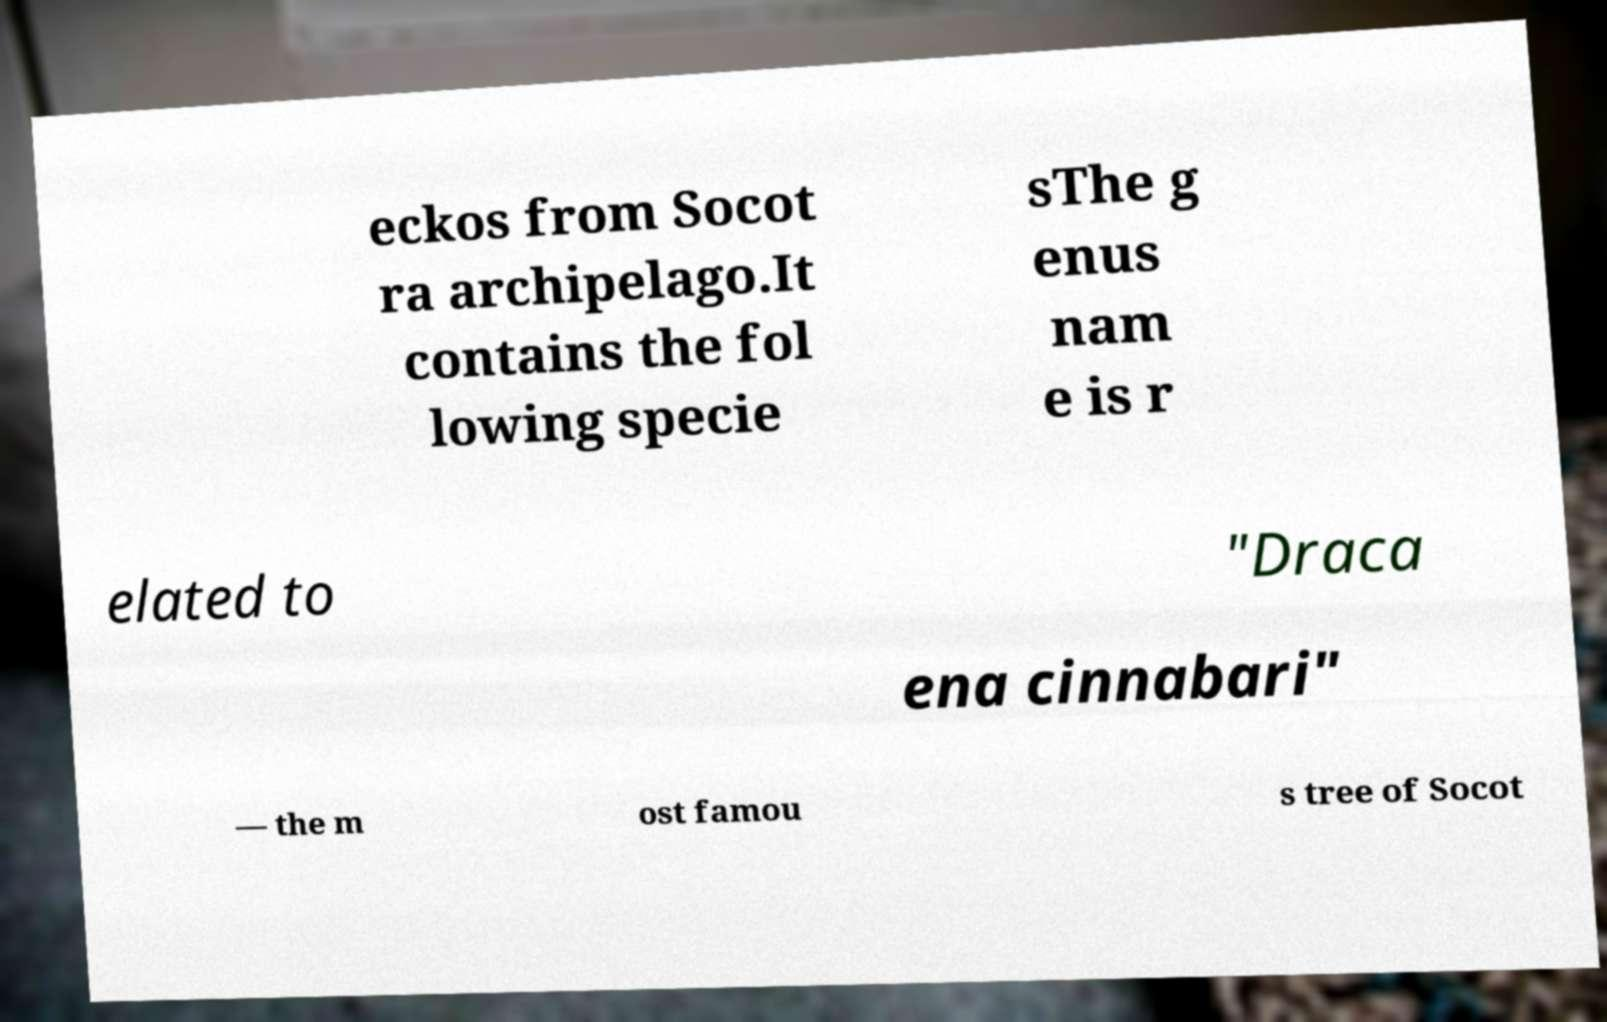There's text embedded in this image that I need extracted. Can you transcribe it verbatim? eckos from Socot ra archipelago.It contains the fol lowing specie sThe g enus nam e is r elated to "Draca ena cinnabari" — the m ost famou s tree of Socot 